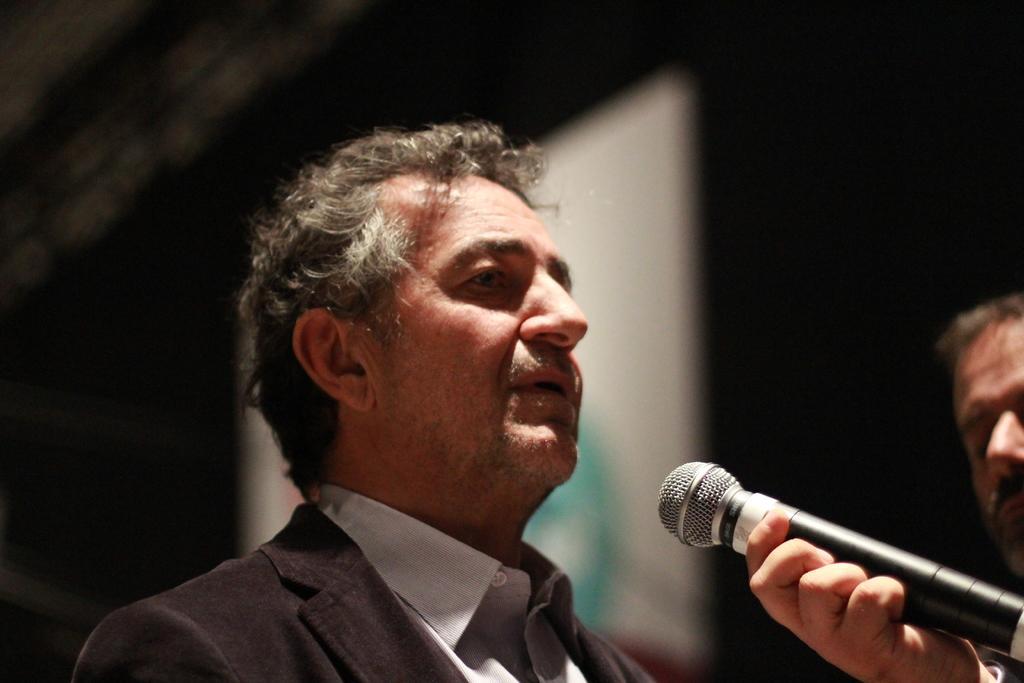Could you give a brief overview of what you see in this image? Here we can see a person in the center and he is speaking on a microphone. 